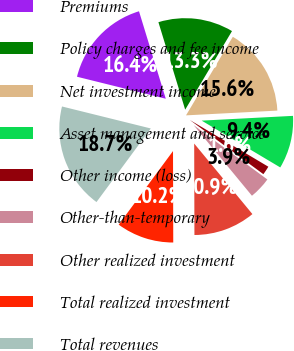<chart> <loc_0><loc_0><loc_500><loc_500><pie_chart><fcel>Premiums<fcel>Policy charges and fee income<fcel>Net investment income<fcel>Asset management and service<fcel>Other income (loss)<fcel>Other-than-temporary<fcel>Other realized investment<fcel>Total realized investment<fcel>Total revenues<nl><fcel>16.41%<fcel>13.28%<fcel>15.62%<fcel>9.38%<fcel>1.56%<fcel>3.91%<fcel>10.94%<fcel>10.16%<fcel>18.75%<nl></chart> 